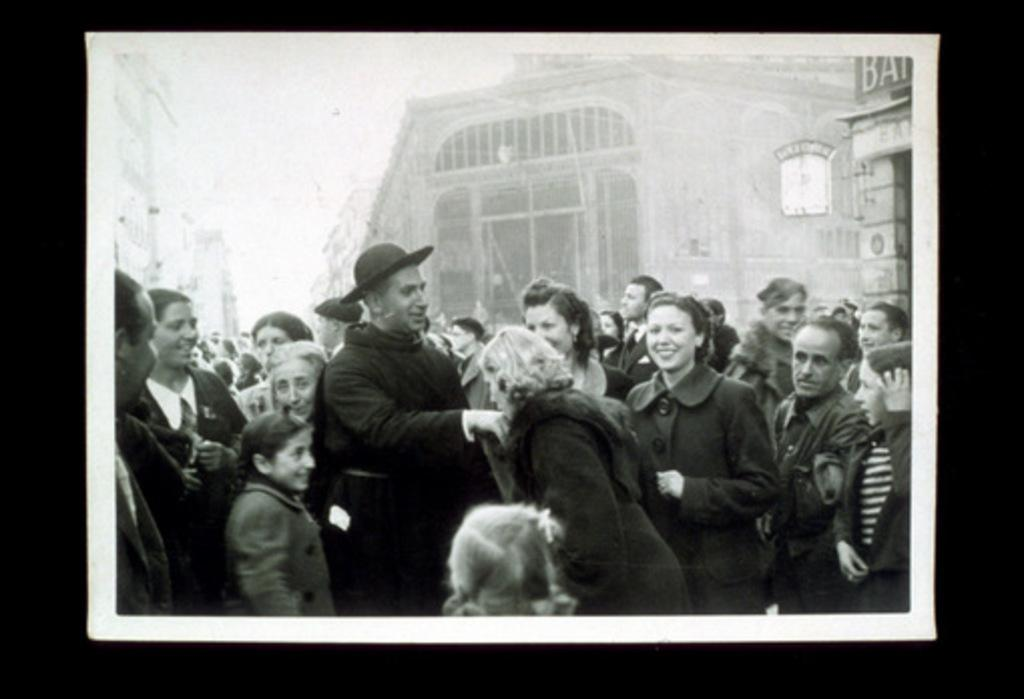What is the main subject of the image? The main subject of the image is a large crowd. Can you describe any specific interactions happening within the crowd? Yes, a woman is kissing the hand of a person within the crowd. What can be seen in the background of the image? There are buildings visible behind the crowd. How many tomatoes are being thrown in the image? There are no tomatoes present in the image, so it is not possible to determine how many might be thrown. 